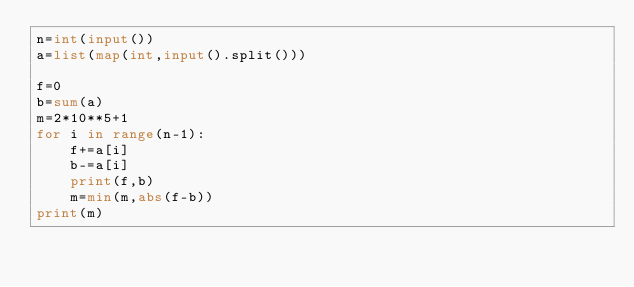<code> <loc_0><loc_0><loc_500><loc_500><_Python_>n=int(input())
a=list(map(int,input().split()))

f=0
b=sum(a)
m=2*10**5+1
for i in range(n-1):
    f+=a[i]
    b-=a[i]
    print(f,b)
    m=min(m,abs(f-b))
print(m)</code> 